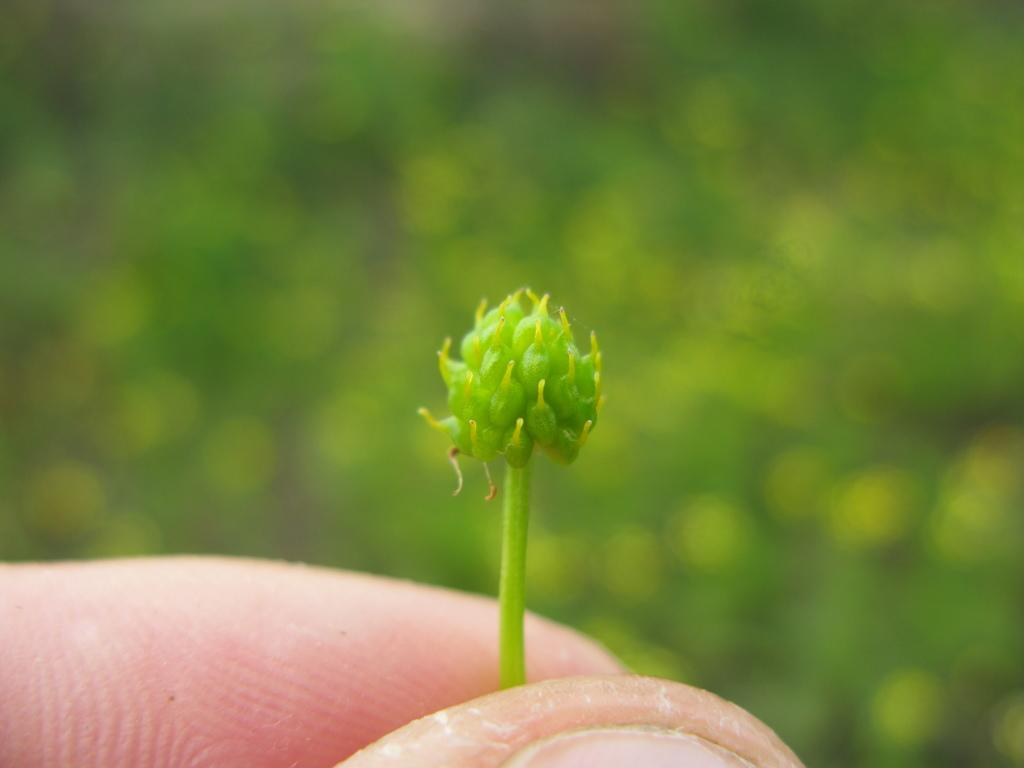What is the main subject of the image? The main subject of the image is a bud. Who is holding the bud in the image? The bud is held by a person. Can you describe the background of the image? The background of the image is blurred. What type of feeling can be seen in the image? There is no feeling present in the image; it is a still image of a bud being held by a person. Can you tell me how many tins are visible in the image? There are no tins present in the image. 